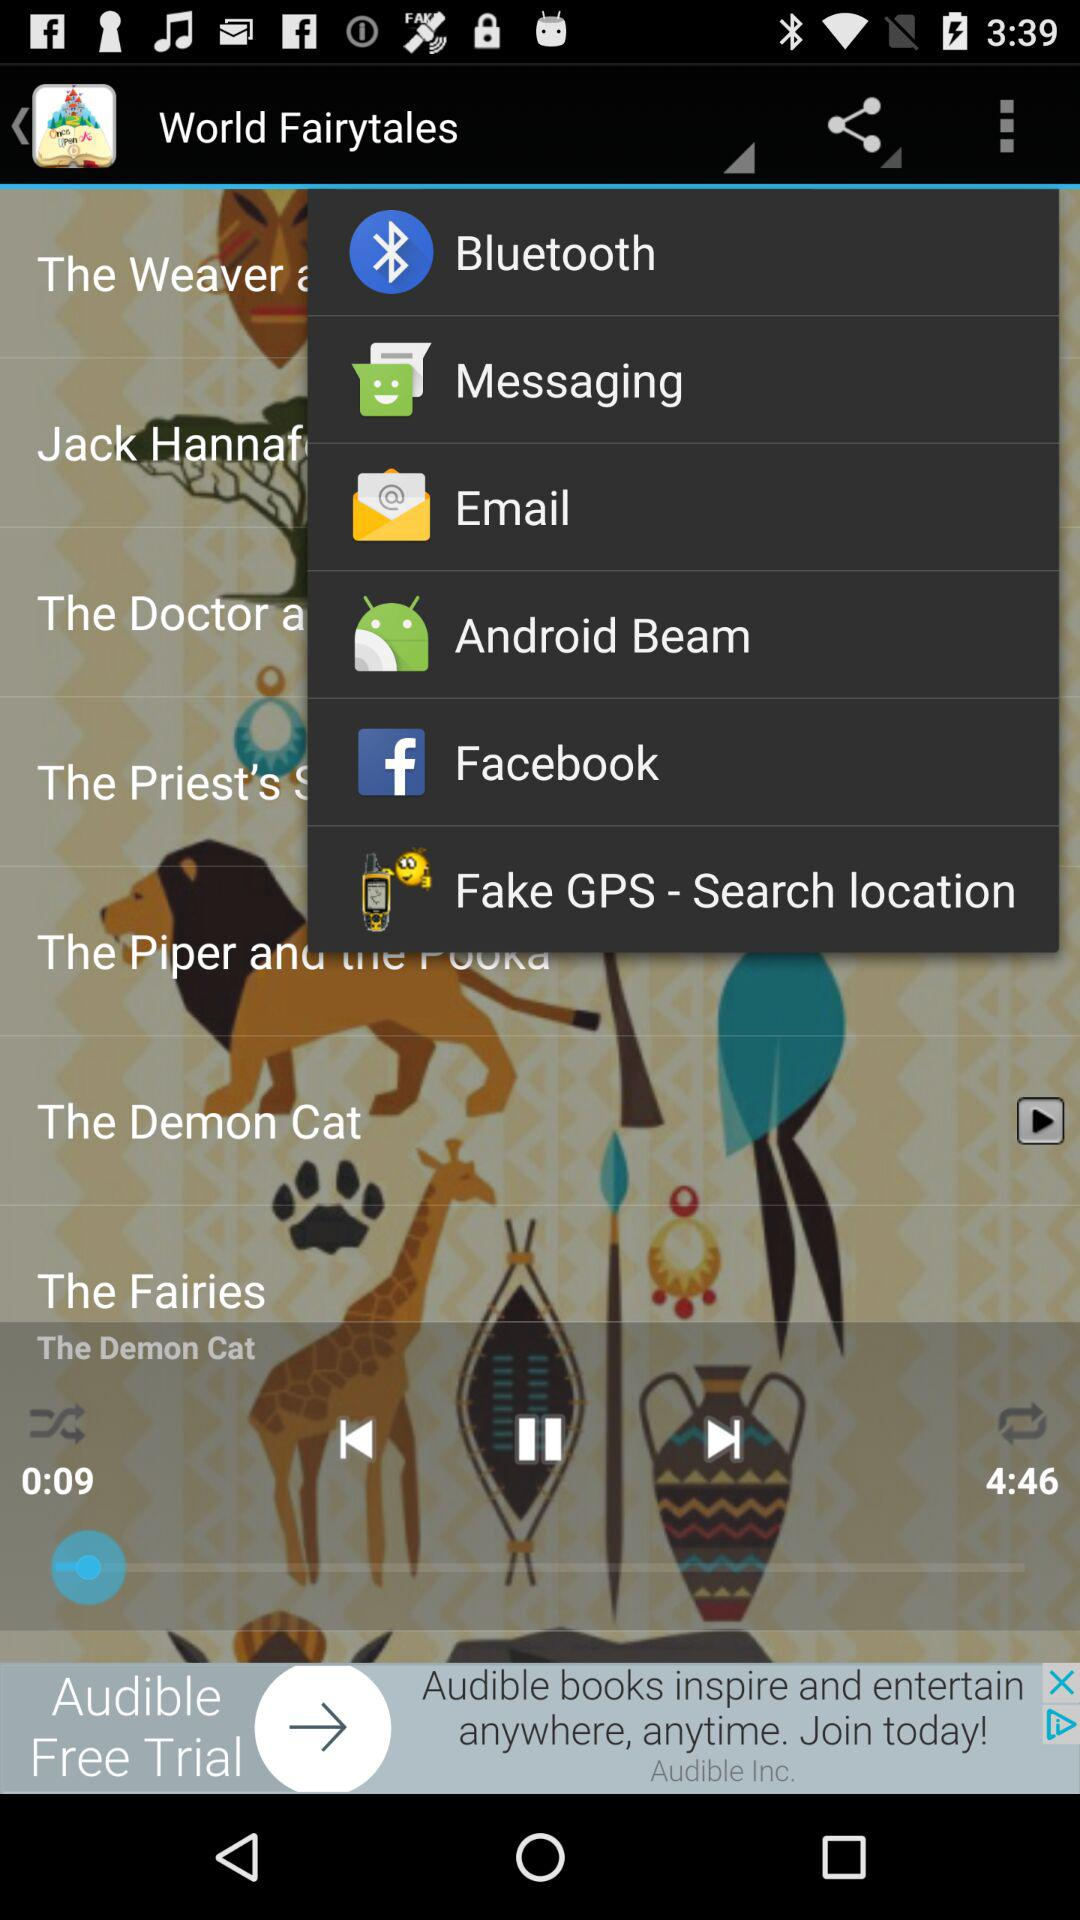What is the duration of the playing audio? The duration is 4:46. 